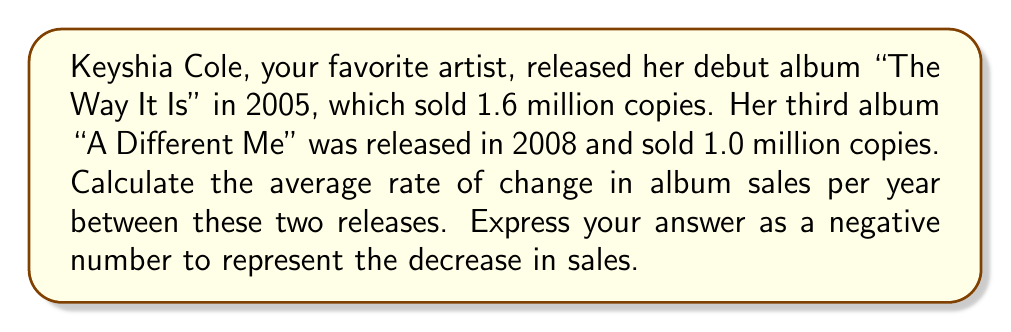Give your solution to this math problem. To calculate the average rate of change in album sales per year, we need to follow these steps:

1. Identify the change in album sales:
   Initial sales (2005): 1.6 million
   Final sales (2008): 1.0 million
   Change in sales: $\Delta y = 1.0 - 1.6 = -0.6$ million

2. Determine the time interval:
   Time interval: $\Delta x = 2008 - 2005 = 3$ years

3. Calculate the average rate of change using the formula:
   $$\text{Average rate of change} = \frac{\Delta y}{\Delta x}$$

4. Substitute the values:
   $$\text{Average rate of change} = \frac{-0.6 \text{ million}}{3 \text{ years}}$$

5. Perform the division:
   $$\text{Average rate of change} = -0.2 \text{ million per year}$$

The negative sign indicates a decrease in sales over time.
Answer: $-0.2$ million per year 